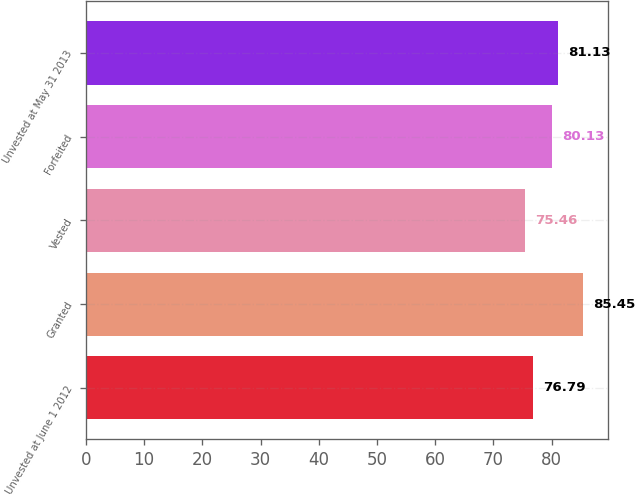Convert chart. <chart><loc_0><loc_0><loc_500><loc_500><bar_chart><fcel>Unvested at June 1 2012<fcel>Granted<fcel>Vested<fcel>Forfeited<fcel>Unvested at May 31 2013<nl><fcel>76.79<fcel>85.45<fcel>75.46<fcel>80.13<fcel>81.13<nl></chart> 